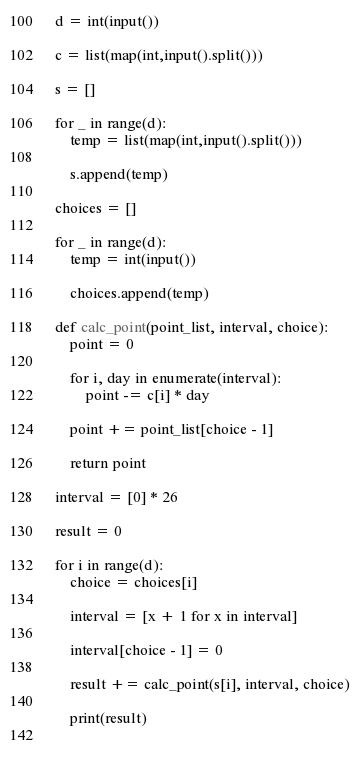Convert code to text. <code><loc_0><loc_0><loc_500><loc_500><_Python_>d = int(input())

c = list(map(int,input().split()))

s = []

for _ in range(d):
    temp = list(map(int,input().split()))

    s.append(temp)

choices = []

for _ in range(d):
    temp = int(input())

    choices.append(temp)

def calc_point(point_list, interval, choice):
    point = 0

    for i, day in enumerate(interval):
        point -= c[i] * day

    point += point_list[choice - 1]

    return point

interval = [0] * 26

result = 0

for i in range(d):
    choice = choices[i]

    interval = [x + 1 for x in interval]

    interval[choice - 1] = 0

    result += calc_point(s[i], interval, choice)

    print(result)
    
    </code> 